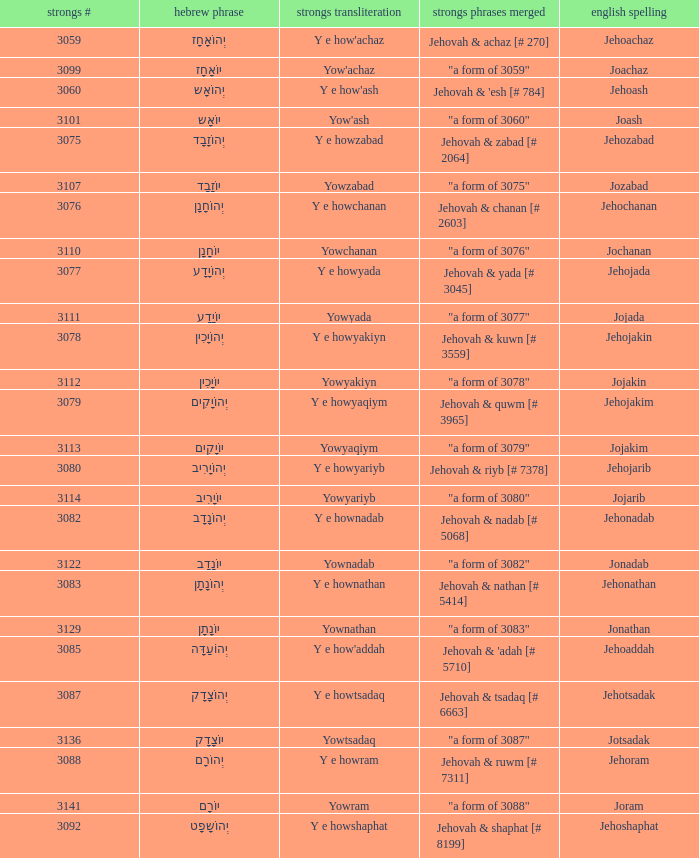What is the strongs transliteration of the hebrew word יוֹחָנָן? Yowchanan. 